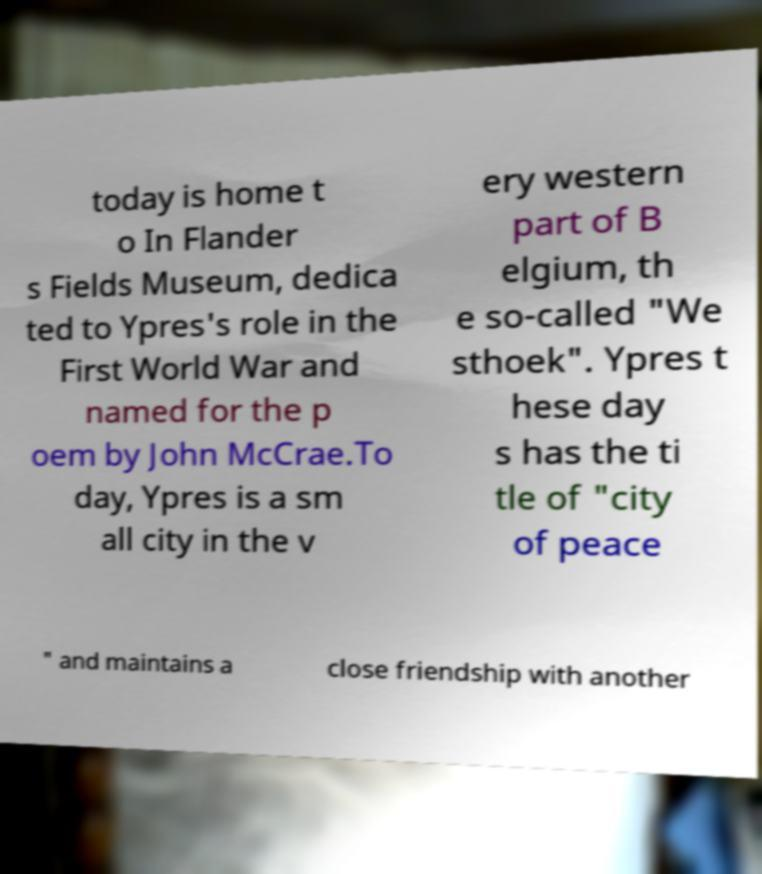I need the written content from this picture converted into text. Can you do that? today is home t o In Flander s Fields Museum, dedica ted to Ypres's role in the First World War and named for the p oem by John McCrae.To day, Ypres is a sm all city in the v ery western part of B elgium, th e so-called "We sthoek". Ypres t hese day s has the ti tle of "city of peace " and maintains a close friendship with another 